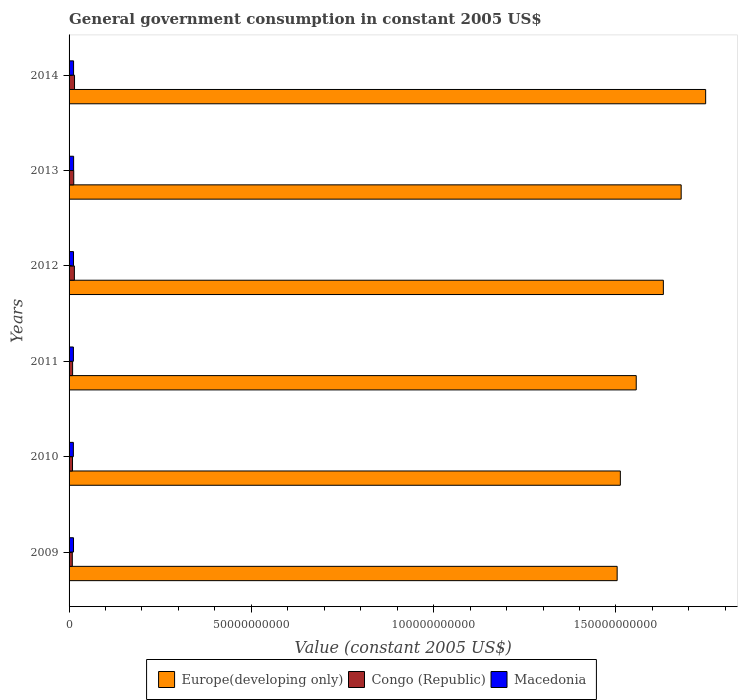Are the number of bars per tick equal to the number of legend labels?
Give a very brief answer. Yes. What is the label of the 6th group of bars from the top?
Your answer should be very brief. 2009. In how many cases, is the number of bars for a given year not equal to the number of legend labels?
Your response must be concise. 0. What is the government conusmption in Congo (Republic) in 2011?
Provide a short and direct response. 9.70e+08. Across all years, what is the maximum government conusmption in Macedonia?
Provide a short and direct response. 1.25e+09. Across all years, what is the minimum government conusmption in Europe(developing only)?
Give a very brief answer. 1.50e+11. In which year was the government conusmption in Congo (Republic) maximum?
Offer a very short reply. 2014. What is the total government conusmption in Congo (Republic) in the graph?
Ensure brevity in your answer.  7.04e+09. What is the difference between the government conusmption in Macedonia in 2010 and that in 2014?
Provide a short and direct response. -5.82e+07. What is the difference between the government conusmption in Congo (Republic) in 2014 and the government conusmption in Macedonia in 2013?
Keep it short and to the point. 2.48e+08. What is the average government conusmption in Macedonia per year?
Give a very brief answer. 1.21e+09. In the year 2014, what is the difference between the government conusmption in Macedonia and government conusmption in Congo (Republic)?
Provide a short and direct response. -2.63e+08. In how many years, is the government conusmption in Europe(developing only) greater than 90000000000 US$?
Ensure brevity in your answer.  6. What is the ratio of the government conusmption in Europe(developing only) in 2011 to that in 2014?
Make the answer very short. 0.89. Is the government conusmption in Congo (Republic) in 2009 less than that in 2010?
Provide a succinct answer. Yes. Is the difference between the government conusmption in Macedonia in 2010 and 2011 greater than the difference between the government conusmption in Congo (Republic) in 2010 and 2011?
Give a very brief answer. Yes. What is the difference between the highest and the second highest government conusmption in Macedonia?
Your answer should be very brief. 1.49e+07. What is the difference between the highest and the lowest government conusmption in Macedonia?
Keep it short and to the point. 7.31e+07. What does the 1st bar from the top in 2011 represents?
Make the answer very short. Macedonia. What does the 2nd bar from the bottom in 2012 represents?
Provide a succinct answer. Congo (Republic). Is it the case that in every year, the sum of the government conusmption in Macedonia and government conusmption in Europe(developing only) is greater than the government conusmption in Congo (Republic)?
Offer a terse response. Yes. What is the difference between two consecutive major ticks on the X-axis?
Provide a succinct answer. 5.00e+1. Does the graph contain any zero values?
Provide a short and direct response. No. How many legend labels are there?
Your answer should be very brief. 3. What is the title of the graph?
Provide a succinct answer. General government consumption in constant 2005 US$. Does "Norway" appear as one of the legend labels in the graph?
Give a very brief answer. No. What is the label or title of the X-axis?
Make the answer very short. Value (constant 2005 US$). What is the label or title of the Y-axis?
Give a very brief answer. Years. What is the Value (constant 2005 US$) in Europe(developing only) in 2009?
Your answer should be compact. 1.50e+11. What is the Value (constant 2005 US$) of Congo (Republic) in 2009?
Offer a very short reply. 8.84e+08. What is the Value (constant 2005 US$) of Macedonia in 2009?
Your answer should be compact. 1.22e+09. What is the Value (constant 2005 US$) in Europe(developing only) in 2010?
Keep it short and to the point. 1.51e+11. What is the Value (constant 2005 US$) of Congo (Republic) in 2010?
Keep it short and to the point. 9.44e+08. What is the Value (constant 2005 US$) of Macedonia in 2010?
Make the answer very short. 1.18e+09. What is the Value (constant 2005 US$) of Europe(developing only) in 2011?
Offer a very short reply. 1.56e+11. What is the Value (constant 2005 US$) in Congo (Republic) in 2011?
Make the answer very short. 9.70e+08. What is the Value (constant 2005 US$) of Macedonia in 2011?
Provide a succinct answer. 1.19e+09. What is the Value (constant 2005 US$) of Europe(developing only) in 2012?
Your response must be concise. 1.63e+11. What is the Value (constant 2005 US$) in Congo (Republic) in 2012?
Provide a short and direct response. 1.46e+09. What is the Value (constant 2005 US$) of Macedonia in 2012?
Ensure brevity in your answer.  1.22e+09. What is the Value (constant 2005 US$) in Europe(developing only) in 2013?
Give a very brief answer. 1.68e+11. What is the Value (constant 2005 US$) in Congo (Republic) in 2013?
Ensure brevity in your answer.  1.28e+09. What is the Value (constant 2005 US$) in Macedonia in 2013?
Your response must be concise. 1.25e+09. What is the Value (constant 2005 US$) in Europe(developing only) in 2014?
Offer a terse response. 1.75e+11. What is the Value (constant 2005 US$) of Congo (Republic) in 2014?
Ensure brevity in your answer.  1.50e+09. What is the Value (constant 2005 US$) of Macedonia in 2014?
Make the answer very short. 1.23e+09. Across all years, what is the maximum Value (constant 2005 US$) in Europe(developing only)?
Your response must be concise. 1.75e+11. Across all years, what is the maximum Value (constant 2005 US$) in Congo (Republic)?
Keep it short and to the point. 1.50e+09. Across all years, what is the maximum Value (constant 2005 US$) in Macedonia?
Your answer should be compact. 1.25e+09. Across all years, what is the minimum Value (constant 2005 US$) of Europe(developing only)?
Make the answer very short. 1.50e+11. Across all years, what is the minimum Value (constant 2005 US$) of Congo (Republic)?
Your answer should be very brief. 8.84e+08. Across all years, what is the minimum Value (constant 2005 US$) of Macedonia?
Your answer should be compact. 1.18e+09. What is the total Value (constant 2005 US$) in Europe(developing only) in the graph?
Provide a short and direct response. 9.63e+11. What is the total Value (constant 2005 US$) in Congo (Republic) in the graph?
Provide a succinct answer. 7.04e+09. What is the total Value (constant 2005 US$) in Macedonia in the graph?
Provide a short and direct response. 7.29e+09. What is the difference between the Value (constant 2005 US$) in Europe(developing only) in 2009 and that in 2010?
Offer a terse response. -8.73e+08. What is the difference between the Value (constant 2005 US$) of Congo (Republic) in 2009 and that in 2010?
Offer a terse response. -5.96e+07. What is the difference between the Value (constant 2005 US$) in Macedonia in 2009 and that in 2010?
Your answer should be very brief. 4.42e+07. What is the difference between the Value (constant 2005 US$) in Europe(developing only) in 2009 and that in 2011?
Ensure brevity in your answer.  -5.23e+09. What is the difference between the Value (constant 2005 US$) in Congo (Republic) in 2009 and that in 2011?
Your answer should be very brief. -8.58e+07. What is the difference between the Value (constant 2005 US$) in Macedonia in 2009 and that in 2011?
Offer a very short reply. 3.02e+07. What is the difference between the Value (constant 2005 US$) in Europe(developing only) in 2009 and that in 2012?
Your response must be concise. -1.27e+1. What is the difference between the Value (constant 2005 US$) in Congo (Republic) in 2009 and that in 2012?
Offer a terse response. -5.71e+08. What is the difference between the Value (constant 2005 US$) in Macedonia in 2009 and that in 2012?
Offer a terse response. 1.22e+06. What is the difference between the Value (constant 2005 US$) of Europe(developing only) in 2009 and that in 2013?
Offer a terse response. -1.76e+1. What is the difference between the Value (constant 2005 US$) in Congo (Republic) in 2009 and that in 2013?
Make the answer very short. -3.99e+08. What is the difference between the Value (constant 2005 US$) in Macedonia in 2009 and that in 2013?
Your answer should be compact. -2.89e+07. What is the difference between the Value (constant 2005 US$) of Europe(developing only) in 2009 and that in 2014?
Offer a very short reply. -2.43e+1. What is the difference between the Value (constant 2005 US$) of Congo (Republic) in 2009 and that in 2014?
Provide a short and direct response. -6.13e+08. What is the difference between the Value (constant 2005 US$) in Macedonia in 2009 and that in 2014?
Your answer should be very brief. -1.40e+07. What is the difference between the Value (constant 2005 US$) of Europe(developing only) in 2010 and that in 2011?
Make the answer very short. -4.36e+09. What is the difference between the Value (constant 2005 US$) of Congo (Republic) in 2010 and that in 2011?
Your answer should be compact. -2.62e+07. What is the difference between the Value (constant 2005 US$) in Macedonia in 2010 and that in 2011?
Provide a succinct answer. -1.40e+07. What is the difference between the Value (constant 2005 US$) of Europe(developing only) in 2010 and that in 2012?
Your response must be concise. -1.18e+1. What is the difference between the Value (constant 2005 US$) of Congo (Republic) in 2010 and that in 2012?
Make the answer very short. -5.11e+08. What is the difference between the Value (constant 2005 US$) in Macedonia in 2010 and that in 2012?
Provide a short and direct response. -4.30e+07. What is the difference between the Value (constant 2005 US$) in Europe(developing only) in 2010 and that in 2013?
Give a very brief answer. -1.67e+1. What is the difference between the Value (constant 2005 US$) in Congo (Republic) in 2010 and that in 2013?
Provide a short and direct response. -3.40e+08. What is the difference between the Value (constant 2005 US$) of Macedonia in 2010 and that in 2013?
Your response must be concise. -7.31e+07. What is the difference between the Value (constant 2005 US$) of Europe(developing only) in 2010 and that in 2014?
Provide a succinct answer. -2.34e+1. What is the difference between the Value (constant 2005 US$) of Congo (Republic) in 2010 and that in 2014?
Your response must be concise. -5.53e+08. What is the difference between the Value (constant 2005 US$) in Macedonia in 2010 and that in 2014?
Offer a terse response. -5.82e+07. What is the difference between the Value (constant 2005 US$) of Europe(developing only) in 2011 and that in 2012?
Provide a short and direct response. -7.44e+09. What is the difference between the Value (constant 2005 US$) in Congo (Republic) in 2011 and that in 2012?
Make the answer very short. -4.85e+08. What is the difference between the Value (constant 2005 US$) in Macedonia in 2011 and that in 2012?
Provide a short and direct response. -2.90e+07. What is the difference between the Value (constant 2005 US$) in Europe(developing only) in 2011 and that in 2013?
Keep it short and to the point. -1.23e+1. What is the difference between the Value (constant 2005 US$) of Congo (Republic) in 2011 and that in 2013?
Give a very brief answer. -3.13e+08. What is the difference between the Value (constant 2005 US$) of Macedonia in 2011 and that in 2013?
Provide a succinct answer. -5.91e+07. What is the difference between the Value (constant 2005 US$) in Europe(developing only) in 2011 and that in 2014?
Provide a succinct answer. -1.90e+1. What is the difference between the Value (constant 2005 US$) of Congo (Republic) in 2011 and that in 2014?
Ensure brevity in your answer.  -5.27e+08. What is the difference between the Value (constant 2005 US$) of Macedonia in 2011 and that in 2014?
Your answer should be very brief. -4.42e+07. What is the difference between the Value (constant 2005 US$) of Europe(developing only) in 2012 and that in 2013?
Ensure brevity in your answer.  -4.88e+09. What is the difference between the Value (constant 2005 US$) of Congo (Republic) in 2012 and that in 2013?
Provide a short and direct response. 1.72e+08. What is the difference between the Value (constant 2005 US$) in Macedonia in 2012 and that in 2013?
Your response must be concise. -3.02e+07. What is the difference between the Value (constant 2005 US$) of Europe(developing only) in 2012 and that in 2014?
Your response must be concise. -1.16e+1. What is the difference between the Value (constant 2005 US$) of Congo (Republic) in 2012 and that in 2014?
Offer a very short reply. -4.19e+07. What is the difference between the Value (constant 2005 US$) in Macedonia in 2012 and that in 2014?
Give a very brief answer. -1.52e+07. What is the difference between the Value (constant 2005 US$) of Europe(developing only) in 2013 and that in 2014?
Your answer should be very brief. -6.72e+09. What is the difference between the Value (constant 2005 US$) of Congo (Republic) in 2013 and that in 2014?
Provide a short and direct response. -2.14e+08. What is the difference between the Value (constant 2005 US$) of Macedonia in 2013 and that in 2014?
Offer a terse response. 1.49e+07. What is the difference between the Value (constant 2005 US$) of Europe(developing only) in 2009 and the Value (constant 2005 US$) of Congo (Republic) in 2010?
Provide a short and direct response. 1.49e+11. What is the difference between the Value (constant 2005 US$) of Europe(developing only) in 2009 and the Value (constant 2005 US$) of Macedonia in 2010?
Your answer should be compact. 1.49e+11. What is the difference between the Value (constant 2005 US$) of Congo (Republic) in 2009 and the Value (constant 2005 US$) of Macedonia in 2010?
Offer a very short reply. -2.92e+08. What is the difference between the Value (constant 2005 US$) of Europe(developing only) in 2009 and the Value (constant 2005 US$) of Congo (Republic) in 2011?
Keep it short and to the point. 1.49e+11. What is the difference between the Value (constant 2005 US$) in Europe(developing only) in 2009 and the Value (constant 2005 US$) in Macedonia in 2011?
Make the answer very short. 1.49e+11. What is the difference between the Value (constant 2005 US$) of Congo (Republic) in 2009 and the Value (constant 2005 US$) of Macedonia in 2011?
Offer a terse response. -3.06e+08. What is the difference between the Value (constant 2005 US$) of Europe(developing only) in 2009 and the Value (constant 2005 US$) of Congo (Republic) in 2012?
Offer a terse response. 1.49e+11. What is the difference between the Value (constant 2005 US$) in Europe(developing only) in 2009 and the Value (constant 2005 US$) in Macedonia in 2012?
Make the answer very short. 1.49e+11. What is the difference between the Value (constant 2005 US$) in Congo (Republic) in 2009 and the Value (constant 2005 US$) in Macedonia in 2012?
Give a very brief answer. -3.35e+08. What is the difference between the Value (constant 2005 US$) of Europe(developing only) in 2009 and the Value (constant 2005 US$) of Congo (Republic) in 2013?
Your response must be concise. 1.49e+11. What is the difference between the Value (constant 2005 US$) in Europe(developing only) in 2009 and the Value (constant 2005 US$) in Macedonia in 2013?
Give a very brief answer. 1.49e+11. What is the difference between the Value (constant 2005 US$) of Congo (Republic) in 2009 and the Value (constant 2005 US$) of Macedonia in 2013?
Keep it short and to the point. -3.65e+08. What is the difference between the Value (constant 2005 US$) of Europe(developing only) in 2009 and the Value (constant 2005 US$) of Congo (Republic) in 2014?
Offer a very short reply. 1.49e+11. What is the difference between the Value (constant 2005 US$) in Europe(developing only) in 2009 and the Value (constant 2005 US$) in Macedonia in 2014?
Keep it short and to the point. 1.49e+11. What is the difference between the Value (constant 2005 US$) of Congo (Republic) in 2009 and the Value (constant 2005 US$) of Macedonia in 2014?
Offer a terse response. -3.50e+08. What is the difference between the Value (constant 2005 US$) in Europe(developing only) in 2010 and the Value (constant 2005 US$) in Congo (Republic) in 2011?
Offer a terse response. 1.50e+11. What is the difference between the Value (constant 2005 US$) in Europe(developing only) in 2010 and the Value (constant 2005 US$) in Macedonia in 2011?
Offer a very short reply. 1.50e+11. What is the difference between the Value (constant 2005 US$) of Congo (Republic) in 2010 and the Value (constant 2005 US$) of Macedonia in 2011?
Keep it short and to the point. -2.46e+08. What is the difference between the Value (constant 2005 US$) of Europe(developing only) in 2010 and the Value (constant 2005 US$) of Congo (Republic) in 2012?
Give a very brief answer. 1.50e+11. What is the difference between the Value (constant 2005 US$) in Europe(developing only) in 2010 and the Value (constant 2005 US$) in Macedonia in 2012?
Ensure brevity in your answer.  1.50e+11. What is the difference between the Value (constant 2005 US$) in Congo (Republic) in 2010 and the Value (constant 2005 US$) in Macedonia in 2012?
Your answer should be very brief. -2.75e+08. What is the difference between the Value (constant 2005 US$) of Europe(developing only) in 2010 and the Value (constant 2005 US$) of Congo (Republic) in 2013?
Ensure brevity in your answer.  1.50e+11. What is the difference between the Value (constant 2005 US$) of Europe(developing only) in 2010 and the Value (constant 2005 US$) of Macedonia in 2013?
Ensure brevity in your answer.  1.50e+11. What is the difference between the Value (constant 2005 US$) in Congo (Republic) in 2010 and the Value (constant 2005 US$) in Macedonia in 2013?
Offer a terse response. -3.05e+08. What is the difference between the Value (constant 2005 US$) in Europe(developing only) in 2010 and the Value (constant 2005 US$) in Congo (Republic) in 2014?
Your response must be concise. 1.50e+11. What is the difference between the Value (constant 2005 US$) in Europe(developing only) in 2010 and the Value (constant 2005 US$) in Macedonia in 2014?
Offer a very short reply. 1.50e+11. What is the difference between the Value (constant 2005 US$) of Congo (Republic) in 2010 and the Value (constant 2005 US$) of Macedonia in 2014?
Make the answer very short. -2.90e+08. What is the difference between the Value (constant 2005 US$) of Europe(developing only) in 2011 and the Value (constant 2005 US$) of Congo (Republic) in 2012?
Your answer should be compact. 1.54e+11. What is the difference between the Value (constant 2005 US$) of Europe(developing only) in 2011 and the Value (constant 2005 US$) of Macedonia in 2012?
Keep it short and to the point. 1.54e+11. What is the difference between the Value (constant 2005 US$) of Congo (Republic) in 2011 and the Value (constant 2005 US$) of Macedonia in 2012?
Offer a very short reply. -2.49e+08. What is the difference between the Value (constant 2005 US$) in Europe(developing only) in 2011 and the Value (constant 2005 US$) in Congo (Republic) in 2013?
Offer a very short reply. 1.54e+11. What is the difference between the Value (constant 2005 US$) of Europe(developing only) in 2011 and the Value (constant 2005 US$) of Macedonia in 2013?
Your answer should be very brief. 1.54e+11. What is the difference between the Value (constant 2005 US$) in Congo (Republic) in 2011 and the Value (constant 2005 US$) in Macedonia in 2013?
Keep it short and to the point. -2.79e+08. What is the difference between the Value (constant 2005 US$) in Europe(developing only) in 2011 and the Value (constant 2005 US$) in Congo (Republic) in 2014?
Provide a short and direct response. 1.54e+11. What is the difference between the Value (constant 2005 US$) of Europe(developing only) in 2011 and the Value (constant 2005 US$) of Macedonia in 2014?
Ensure brevity in your answer.  1.54e+11. What is the difference between the Value (constant 2005 US$) in Congo (Republic) in 2011 and the Value (constant 2005 US$) in Macedonia in 2014?
Give a very brief answer. -2.64e+08. What is the difference between the Value (constant 2005 US$) in Europe(developing only) in 2012 and the Value (constant 2005 US$) in Congo (Republic) in 2013?
Provide a short and direct response. 1.62e+11. What is the difference between the Value (constant 2005 US$) in Europe(developing only) in 2012 and the Value (constant 2005 US$) in Macedonia in 2013?
Your response must be concise. 1.62e+11. What is the difference between the Value (constant 2005 US$) in Congo (Republic) in 2012 and the Value (constant 2005 US$) in Macedonia in 2013?
Make the answer very short. 2.06e+08. What is the difference between the Value (constant 2005 US$) of Europe(developing only) in 2012 and the Value (constant 2005 US$) of Congo (Republic) in 2014?
Your response must be concise. 1.62e+11. What is the difference between the Value (constant 2005 US$) of Europe(developing only) in 2012 and the Value (constant 2005 US$) of Macedonia in 2014?
Your response must be concise. 1.62e+11. What is the difference between the Value (constant 2005 US$) of Congo (Republic) in 2012 and the Value (constant 2005 US$) of Macedonia in 2014?
Offer a terse response. 2.21e+08. What is the difference between the Value (constant 2005 US$) in Europe(developing only) in 2013 and the Value (constant 2005 US$) in Congo (Republic) in 2014?
Ensure brevity in your answer.  1.66e+11. What is the difference between the Value (constant 2005 US$) in Europe(developing only) in 2013 and the Value (constant 2005 US$) in Macedonia in 2014?
Your response must be concise. 1.67e+11. What is the difference between the Value (constant 2005 US$) in Congo (Republic) in 2013 and the Value (constant 2005 US$) in Macedonia in 2014?
Provide a succinct answer. 4.94e+07. What is the average Value (constant 2005 US$) of Europe(developing only) per year?
Provide a short and direct response. 1.60e+11. What is the average Value (constant 2005 US$) in Congo (Republic) per year?
Your answer should be very brief. 1.17e+09. What is the average Value (constant 2005 US$) in Macedonia per year?
Your response must be concise. 1.21e+09. In the year 2009, what is the difference between the Value (constant 2005 US$) of Europe(developing only) and Value (constant 2005 US$) of Congo (Republic)?
Your response must be concise. 1.49e+11. In the year 2009, what is the difference between the Value (constant 2005 US$) of Europe(developing only) and Value (constant 2005 US$) of Macedonia?
Make the answer very short. 1.49e+11. In the year 2009, what is the difference between the Value (constant 2005 US$) in Congo (Republic) and Value (constant 2005 US$) in Macedonia?
Your answer should be very brief. -3.36e+08. In the year 2010, what is the difference between the Value (constant 2005 US$) in Europe(developing only) and Value (constant 2005 US$) in Congo (Republic)?
Give a very brief answer. 1.50e+11. In the year 2010, what is the difference between the Value (constant 2005 US$) in Europe(developing only) and Value (constant 2005 US$) in Macedonia?
Your response must be concise. 1.50e+11. In the year 2010, what is the difference between the Value (constant 2005 US$) of Congo (Republic) and Value (constant 2005 US$) of Macedonia?
Your response must be concise. -2.32e+08. In the year 2011, what is the difference between the Value (constant 2005 US$) of Europe(developing only) and Value (constant 2005 US$) of Congo (Republic)?
Your response must be concise. 1.55e+11. In the year 2011, what is the difference between the Value (constant 2005 US$) in Europe(developing only) and Value (constant 2005 US$) in Macedonia?
Offer a terse response. 1.54e+11. In the year 2011, what is the difference between the Value (constant 2005 US$) in Congo (Republic) and Value (constant 2005 US$) in Macedonia?
Your answer should be very brief. -2.20e+08. In the year 2012, what is the difference between the Value (constant 2005 US$) of Europe(developing only) and Value (constant 2005 US$) of Congo (Republic)?
Keep it short and to the point. 1.62e+11. In the year 2012, what is the difference between the Value (constant 2005 US$) of Europe(developing only) and Value (constant 2005 US$) of Macedonia?
Provide a succinct answer. 1.62e+11. In the year 2012, what is the difference between the Value (constant 2005 US$) in Congo (Republic) and Value (constant 2005 US$) in Macedonia?
Offer a very short reply. 2.37e+08. In the year 2013, what is the difference between the Value (constant 2005 US$) in Europe(developing only) and Value (constant 2005 US$) in Congo (Republic)?
Provide a short and direct response. 1.67e+11. In the year 2013, what is the difference between the Value (constant 2005 US$) of Europe(developing only) and Value (constant 2005 US$) of Macedonia?
Your response must be concise. 1.67e+11. In the year 2013, what is the difference between the Value (constant 2005 US$) in Congo (Republic) and Value (constant 2005 US$) in Macedonia?
Keep it short and to the point. 3.45e+07. In the year 2014, what is the difference between the Value (constant 2005 US$) of Europe(developing only) and Value (constant 2005 US$) of Congo (Republic)?
Offer a very short reply. 1.73e+11. In the year 2014, what is the difference between the Value (constant 2005 US$) of Europe(developing only) and Value (constant 2005 US$) of Macedonia?
Keep it short and to the point. 1.73e+11. In the year 2014, what is the difference between the Value (constant 2005 US$) of Congo (Republic) and Value (constant 2005 US$) of Macedonia?
Keep it short and to the point. 2.63e+08. What is the ratio of the Value (constant 2005 US$) of Congo (Republic) in 2009 to that in 2010?
Offer a very short reply. 0.94. What is the ratio of the Value (constant 2005 US$) of Macedonia in 2009 to that in 2010?
Provide a succinct answer. 1.04. What is the ratio of the Value (constant 2005 US$) of Europe(developing only) in 2009 to that in 2011?
Your response must be concise. 0.97. What is the ratio of the Value (constant 2005 US$) in Congo (Republic) in 2009 to that in 2011?
Make the answer very short. 0.91. What is the ratio of the Value (constant 2005 US$) of Macedonia in 2009 to that in 2011?
Offer a terse response. 1.03. What is the ratio of the Value (constant 2005 US$) of Europe(developing only) in 2009 to that in 2012?
Your response must be concise. 0.92. What is the ratio of the Value (constant 2005 US$) of Congo (Republic) in 2009 to that in 2012?
Keep it short and to the point. 0.61. What is the ratio of the Value (constant 2005 US$) of Macedonia in 2009 to that in 2012?
Offer a very short reply. 1. What is the ratio of the Value (constant 2005 US$) in Europe(developing only) in 2009 to that in 2013?
Your answer should be compact. 0.9. What is the ratio of the Value (constant 2005 US$) in Congo (Republic) in 2009 to that in 2013?
Your answer should be compact. 0.69. What is the ratio of the Value (constant 2005 US$) of Macedonia in 2009 to that in 2013?
Provide a short and direct response. 0.98. What is the ratio of the Value (constant 2005 US$) in Europe(developing only) in 2009 to that in 2014?
Ensure brevity in your answer.  0.86. What is the ratio of the Value (constant 2005 US$) in Congo (Republic) in 2009 to that in 2014?
Keep it short and to the point. 0.59. What is the ratio of the Value (constant 2005 US$) of Macedonia in 2009 to that in 2014?
Your answer should be very brief. 0.99. What is the ratio of the Value (constant 2005 US$) in Europe(developing only) in 2010 to that in 2011?
Make the answer very short. 0.97. What is the ratio of the Value (constant 2005 US$) of Europe(developing only) in 2010 to that in 2012?
Your answer should be very brief. 0.93. What is the ratio of the Value (constant 2005 US$) of Congo (Republic) in 2010 to that in 2012?
Ensure brevity in your answer.  0.65. What is the ratio of the Value (constant 2005 US$) of Macedonia in 2010 to that in 2012?
Make the answer very short. 0.96. What is the ratio of the Value (constant 2005 US$) of Europe(developing only) in 2010 to that in 2013?
Provide a short and direct response. 0.9. What is the ratio of the Value (constant 2005 US$) in Congo (Republic) in 2010 to that in 2013?
Give a very brief answer. 0.74. What is the ratio of the Value (constant 2005 US$) of Macedonia in 2010 to that in 2013?
Offer a very short reply. 0.94. What is the ratio of the Value (constant 2005 US$) of Europe(developing only) in 2010 to that in 2014?
Offer a terse response. 0.87. What is the ratio of the Value (constant 2005 US$) of Congo (Republic) in 2010 to that in 2014?
Your response must be concise. 0.63. What is the ratio of the Value (constant 2005 US$) of Macedonia in 2010 to that in 2014?
Provide a short and direct response. 0.95. What is the ratio of the Value (constant 2005 US$) of Europe(developing only) in 2011 to that in 2012?
Make the answer very short. 0.95. What is the ratio of the Value (constant 2005 US$) of Congo (Republic) in 2011 to that in 2012?
Ensure brevity in your answer.  0.67. What is the ratio of the Value (constant 2005 US$) in Macedonia in 2011 to that in 2012?
Ensure brevity in your answer.  0.98. What is the ratio of the Value (constant 2005 US$) in Europe(developing only) in 2011 to that in 2013?
Your answer should be compact. 0.93. What is the ratio of the Value (constant 2005 US$) in Congo (Republic) in 2011 to that in 2013?
Provide a succinct answer. 0.76. What is the ratio of the Value (constant 2005 US$) in Macedonia in 2011 to that in 2013?
Give a very brief answer. 0.95. What is the ratio of the Value (constant 2005 US$) of Europe(developing only) in 2011 to that in 2014?
Give a very brief answer. 0.89. What is the ratio of the Value (constant 2005 US$) of Congo (Republic) in 2011 to that in 2014?
Provide a succinct answer. 0.65. What is the ratio of the Value (constant 2005 US$) in Macedonia in 2011 to that in 2014?
Keep it short and to the point. 0.96. What is the ratio of the Value (constant 2005 US$) in Europe(developing only) in 2012 to that in 2013?
Ensure brevity in your answer.  0.97. What is the ratio of the Value (constant 2005 US$) of Congo (Republic) in 2012 to that in 2013?
Offer a very short reply. 1.13. What is the ratio of the Value (constant 2005 US$) of Macedonia in 2012 to that in 2013?
Offer a very short reply. 0.98. What is the ratio of the Value (constant 2005 US$) in Europe(developing only) in 2012 to that in 2014?
Provide a short and direct response. 0.93. What is the ratio of the Value (constant 2005 US$) of Congo (Republic) in 2012 to that in 2014?
Your answer should be very brief. 0.97. What is the ratio of the Value (constant 2005 US$) in Europe(developing only) in 2013 to that in 2014?
Make the answer very short. 0.96. What is the ratio of the Value (constant 2005 US$) in Congo (Republic) in 2013 to that in 2014?
Make the answer very short. 0.86. What is the ratio of the Value (constant 2005 US$) in Macedonia in 2013 to that in 2014?
Provide a short and direct response. 1.01. What is the difference between the highest and the second highest Value (constant 2005 US$) in Europe(developing only)?
Make the answer very short. 6.72e+09. What is the difference between the highest and the second highest Value (constant 2005 US$) in Congo (Republic)?
Provide a succinct answer. 4.19e+07. What is the difference between the highest and the second highest Value (constant 2005 US$) of Macedonia?
Keep it short and to the point. 1.49e+07. What is the difference between the highest and the lowest Value (constant 2005 US$) in Europe(developing only)?
Your response must be concise. 2.43e+1. What is the difference between the highest and the lowest Value (constant 2005 US$) in Congo (Republic)?
Give a very brief answer. 6.13e+08. What is the difference between the highest and the lowest Value (constant 2005 US$) in Macedonia?
Your response must be concise. 7.31e+07. 